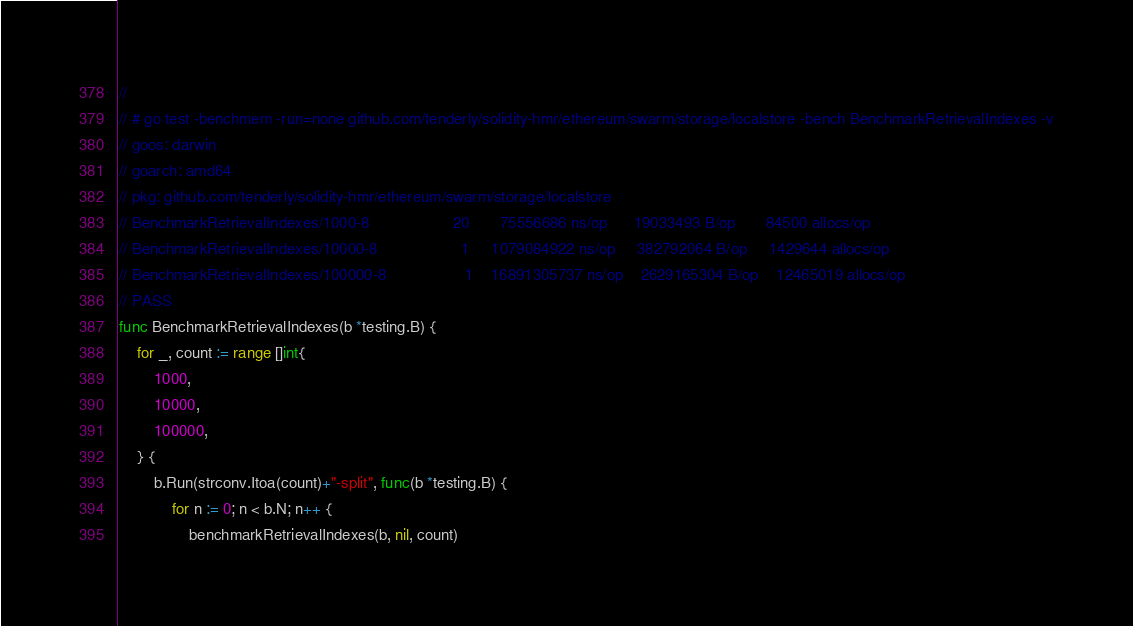Convert code to text. <code><loc_0><loc_0><loc_500><loc_500><_Go_>//
// # go test -benchmem -run=none github.com/tenderly/solidity-hmr/ethereum/swarm/storage/localstore -bench BenchmarkRetrievalIndexes -v
// goos: darwin
// goarch: amd64
// pkg: github.com/tenderly/solidity-hmr/ethereum/swarm/storage/localstore
// BenchmarkRetrievalIndexes/1000-8         	      20       75556686 ns/op      19033493 B/op       84500 allocs/op
// BenchmarkRetrievalIndexes/10000-8        	       1     1079084922 ns/op     382792064 B/op     1429644 allocs/op
// BenchmarkRetrievalIndexes/100000-8       	       1    16891305737 ns/op    2629165304 B/op    12465019 allocs/op
// PASS
func BenchmarkRetrievalIndexes(b *testing.B) {
	for _, count := range []int{
		1000,
		10000,
		100000,
	} {
		b.Run(strconv.Itoa(count)+"-split", func(b *testing.B) {
			for n := 0; n < b.N; n++ {
				benchmarkRetrievalIndexes(b, nil, count)</code> 